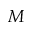<formula> <loc_0><loc_0><loc_500><loc_500>M</formula> 